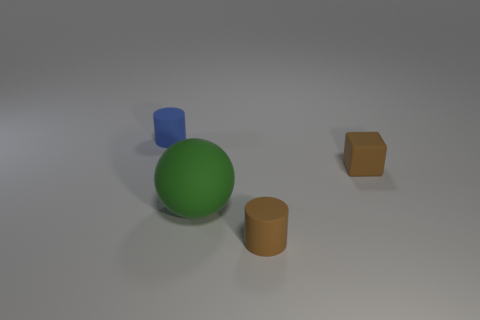Add 1 spheres. How many objects exist? 5 Subtract all balls. How many objects are left? 3 Add 4 green rubber objects. How many green rubber objects are left? 5 Add 2 brown rubber blocks. How many brown rubber blocks exist? 3 Subtract 0 cyan cylinders. How many objects are left? 4 Subtract all purple cylinders. Subtract all big green rubber balls. How many objects are left? 3 